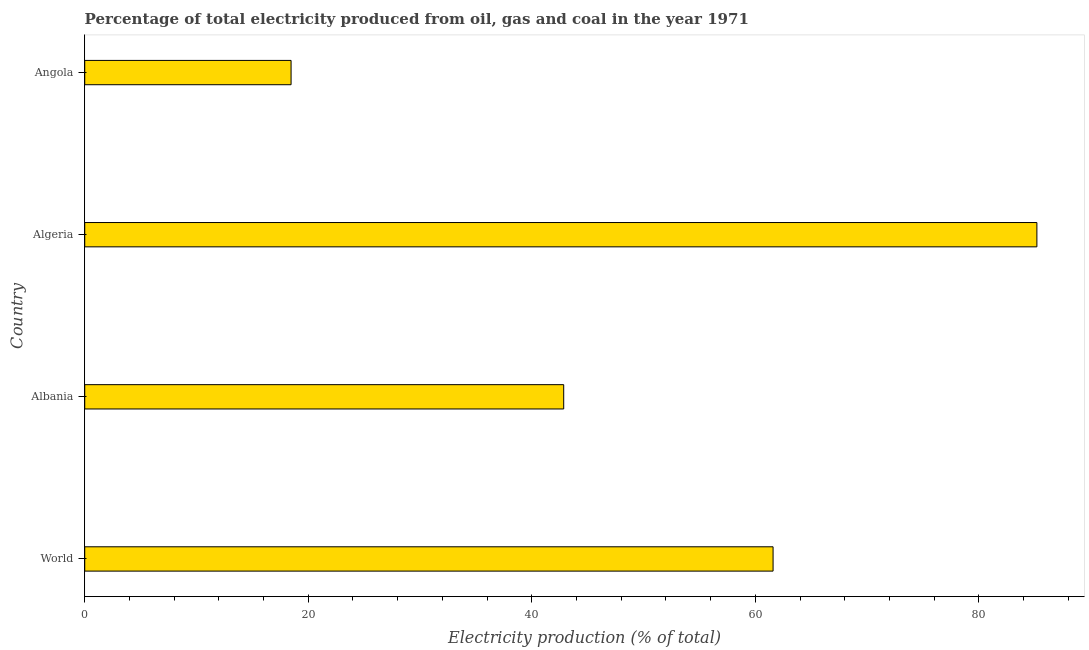Does the graph contain any zero values?
Provide a short and direct response. No. What is the title of the graph?
Offer a terse response. Percentage of total electricity produced from oil, gas and coal in the year 1971. What is the label or title of the X-axis?
Your answer should be very brief. Electricity production (% of total). What is the label or title of the Y-axis?
Your answer should be compact. Country. What is the electricity production in Albania?
Provide a short and direct response. 42.86. Across all countries, what is the maximum electricity production?
Keep it short and to the point. 85.2. Across all countries, what is the minimum electricity production?
Give a very brief answer. 18.46. In which country was the electricity production maximum?
Your response must be concise. Algeria. In which country was the electricity production minimum?
Give a very brief answer. Angola. What is the sum of the electricity production?
Offer a very short reply. 208.11. What is the difference between the electricity production in Albania and Algeria?
Give a very brief answer. -42.34. What is the average electricity production per country?
Your answer should be very brief. 52.03. What is the median electricity production?
Your answer should be very brief. 52.22. What is the ratio of the electricity production in Algeria to that in World?
Make the answer very short. 1.38. Is the electricity production in Albania less than that in Algeria?
Provide a short and direct response. Yes. Is the difference between the electricity production in Albania and Algeria greater than the difference between any two countries?
Make the answer very short. No. What is the difference between the highest and the second highest electricity production?
Ensure brevity in your answer.  23.6. Is the sum of the electricity production in Algeria and Angola greater than the maximum electricity production across all countries?
Your answer should be very brief. Yes. What is the difference between the highest and the lowest electricity production?
Keep it short and to the point. 66.73. In how many countries, is the electricity production greater than the average electricity production taken over all countries?
Keep it short and to the point. 2. How many bars are there?
Make the answer very short. 4. Are all the bars in the graph horizontal?
Provide a succinct answer. Yes. How many countries are there in the graph?
Keep it short and to the point. 4. What is the difference between two consecutive major ticks on the X-axis?
Offer a very short reply. 20. Are the values on the major ticks of X-axis written in scientific E-notation?
Give a very brief answer. No. What is the Electricity production (% of total) of World?
Ensure brevity in your answer.  61.59. What is the Electricity production (% of total) in Albania?
Make the answer very short. 42.86. What is the Electricity production (% of total) in Algeria?
Your response must be concise. 85.2. What is the Electricity production (% of total) in Angola?
Provide a succinct answer. 18.46. What is the difference between the Electricity production (% of total) in World and Albania?
Provide a short and direct response. 18.73. What is the difference between the Electricity production (% of total) in World and Algeria?
Your answer should be compact. -23.6. What is the difference between the Electricity production (% of total) in World and Angola?
Give a very brief answer. 43.13. What is the difference between the Electricity production (% of total) in Albania and Algeria?
Provide a short and direct response. -42.34. What is the difference between the Electricity production (% of total) in Albania and Angola?
Make the answer very short. 24.39. What is the difference between the Electricity production (% of total) in Algeria and Angola?
Keep it short and to the point. 66.73. What is the ratio of the Electricity production (% of total) in World to that in Albania?
Keep it short and to the point. 1.44. What is the ratio of the Electricity production (% of total) in World to that in Algeria?
Your answer should be compact. 0.72. What is the ratio of the Electricity production (% of total) in World to that in Angola?
Ensure brevity in your answer.  3.34. What is the ratio of the Electricity production (% of total) in Albania to that in Algeria?
Give a very brief answer. 0.5. What is the ratio of the Electricity production (% of total) in Albania to that in Angola?
Provide a short and direct response. 2.32. What is the ratio of the Electricity production (% of total) in Algeria to that in Angola?
Keep it short and to the point. 4.61. 